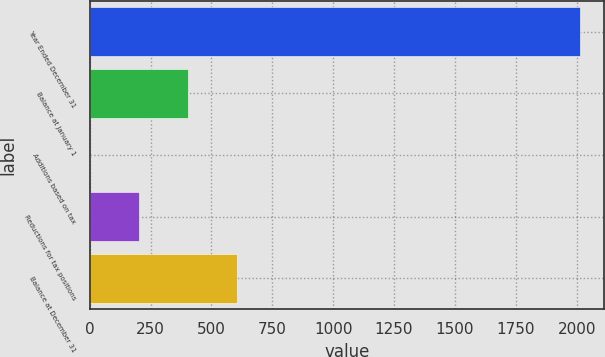Convert chart to OTSL. <chart><loc_0><loc_0><loc_500><loc_500><bar_chart><fcel>Year Ended December 31<fcel>Balance at January 1<fcel>Additions based on tax<fcel>Reductions for tax positions<fcel>Balance at December 31<nl><fcel>2013<fcel>404.2<fcel>2<fcel>203.1<fcel>605.3<nl></chart> 